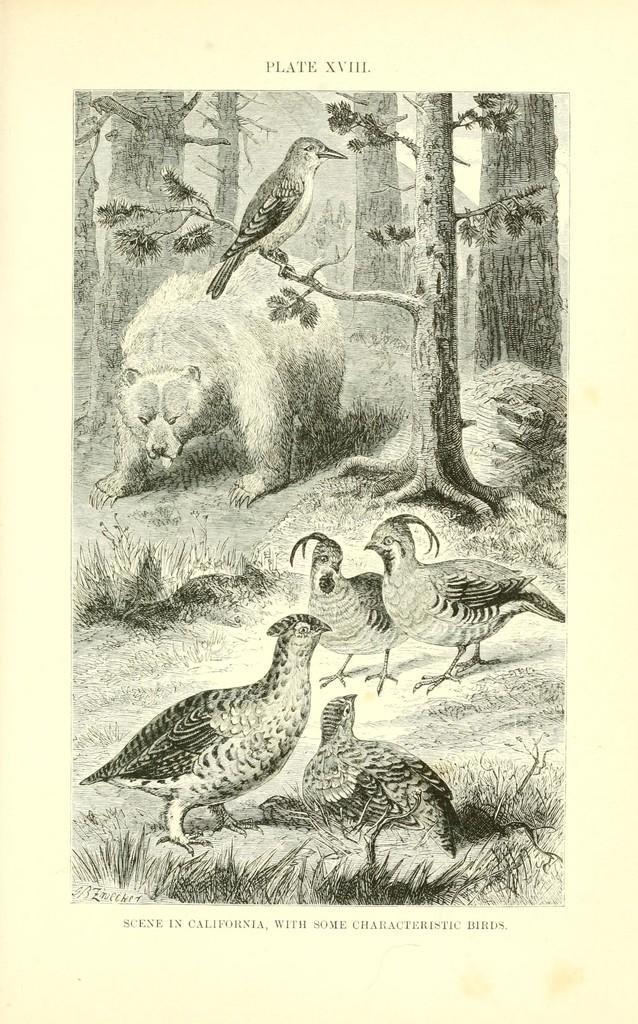What type of sketches can be seen in the image? There are sketches of birds, plants, and trees in the image. What is the medium for these sketches? The sketches are on a paper. Are there any words or phrases in the image? Yes, there is text present in the image. What type of haircut is the bird getting in the image? There is no haircut depicted in the image, as it features sketches of birds, plants, and trees. How does the team contribute to the sketches in the image? There is no team present in the image, as it only contains sketches of birds, plants, and trees on a paper with accompanying text. 